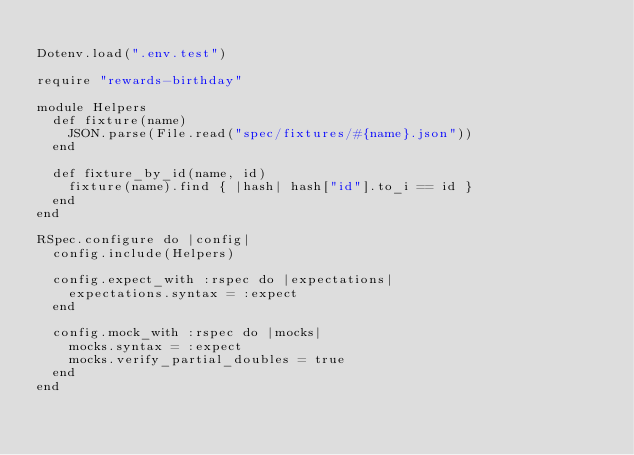<code> <loc_0><loc_0><loc_500><loc_500><_Ruby_>
Dotenv.load(".env.test")

require "rewards-birthday"

module Helpers
  def fixture(name)
    JSON.parse(File.read("spec/fixtures/#{name}.json"))
  end

  def fixture_by_id(name, id)
    fixture(name).find { |hash| hash["id"].to_i == id }
  end
end

RSpec.configure do |config|
  config.include(Helpers)

  config.expect_with :rspec do |expectations|
    expectations.syntax = :expect
  end

  config.mock_with :rspec do |mocks|
    mocks.syntax = :expect
    mocks.verify_partial_doubles = true
  end
end
</code> 